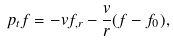<formula> <loc_0><loc_0><loc_500><loc_500>\ p _ { t } f = - v f _ { , r } - \frac { v } { r } ( f - f _ { 0 } ) ,</formula> 